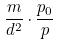<formula> <loc_0><loc_0><loc_500><loc_500>\frac { m } { d ^ { 2 } } \cdot \frac { p _ { 0 } } { p }</formula> 